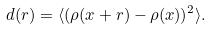<formula> <loc_0><loc_0><loc_500><loc_500>d ( r ) = \langle ( \rho ( { x } + { r } ) - \rho ( { x } ) ) ^ { 2 } \rangle .</formula> 